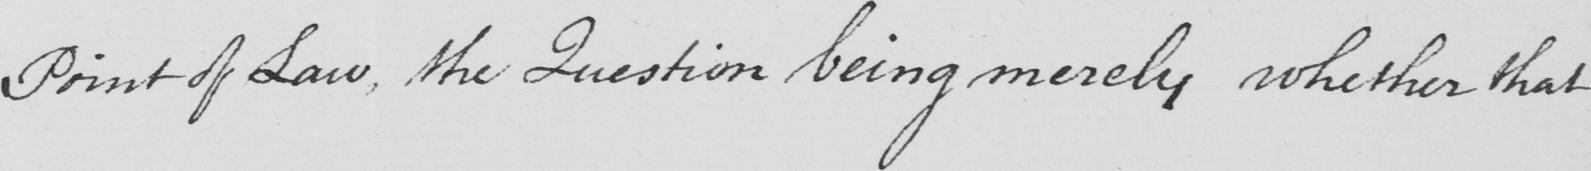Transcribe the text shown in this historical manuscript line. Point of Law , the Question being merely whether that 